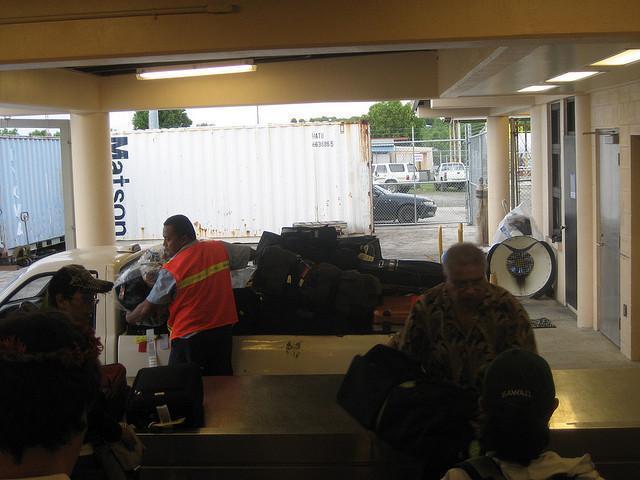How many suitcases are there?
Give a very brief answer. 2. How many people are there?
Give a very brief answer. 4. How many trucks are there?
Give a very brief answer. 2. 